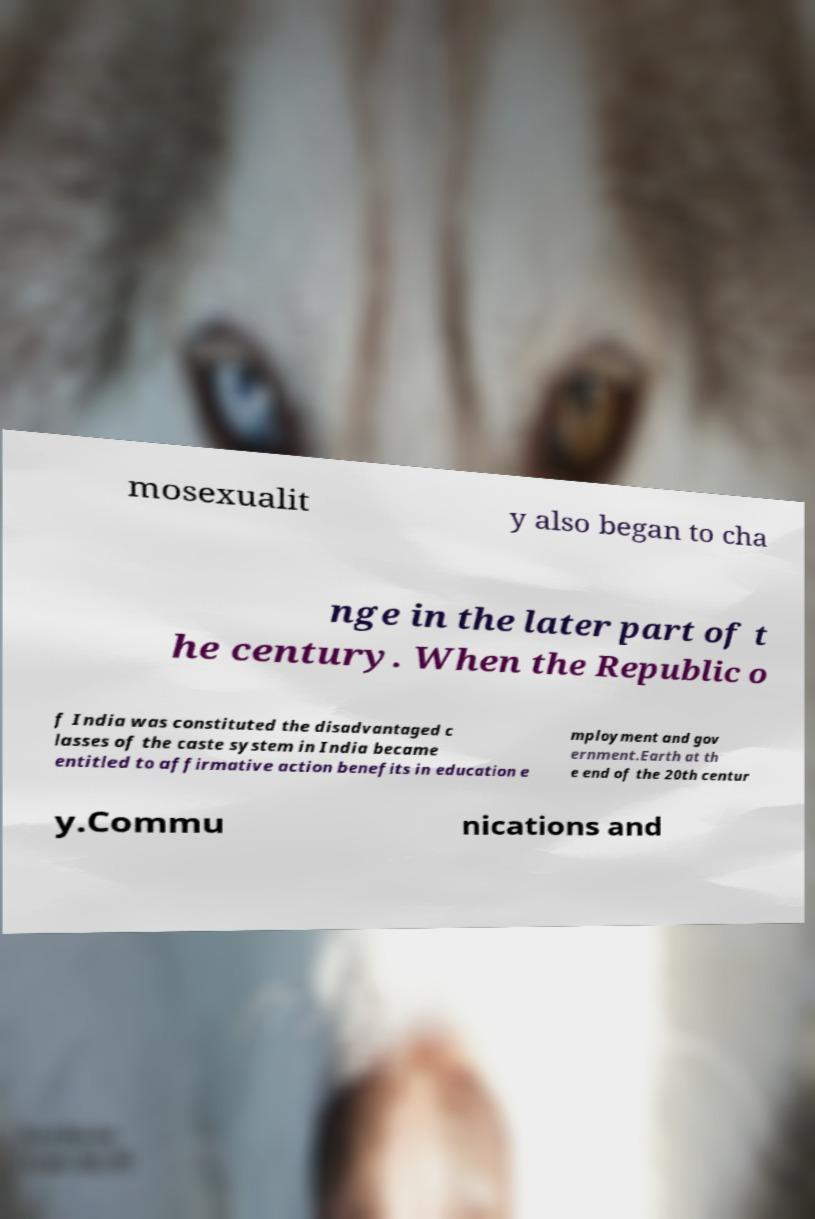Please read and relay the text visible in this image. What does it say? mosexualit y also began to cha nge in the later part of t he century. When the Republic o f India was constituted the disadvantaged c lasses of the caste system in India became entitled to affirmative action benefits in education e mployment and gov ernment.Earth at th e end of the 20th centur y.Commu nications and 